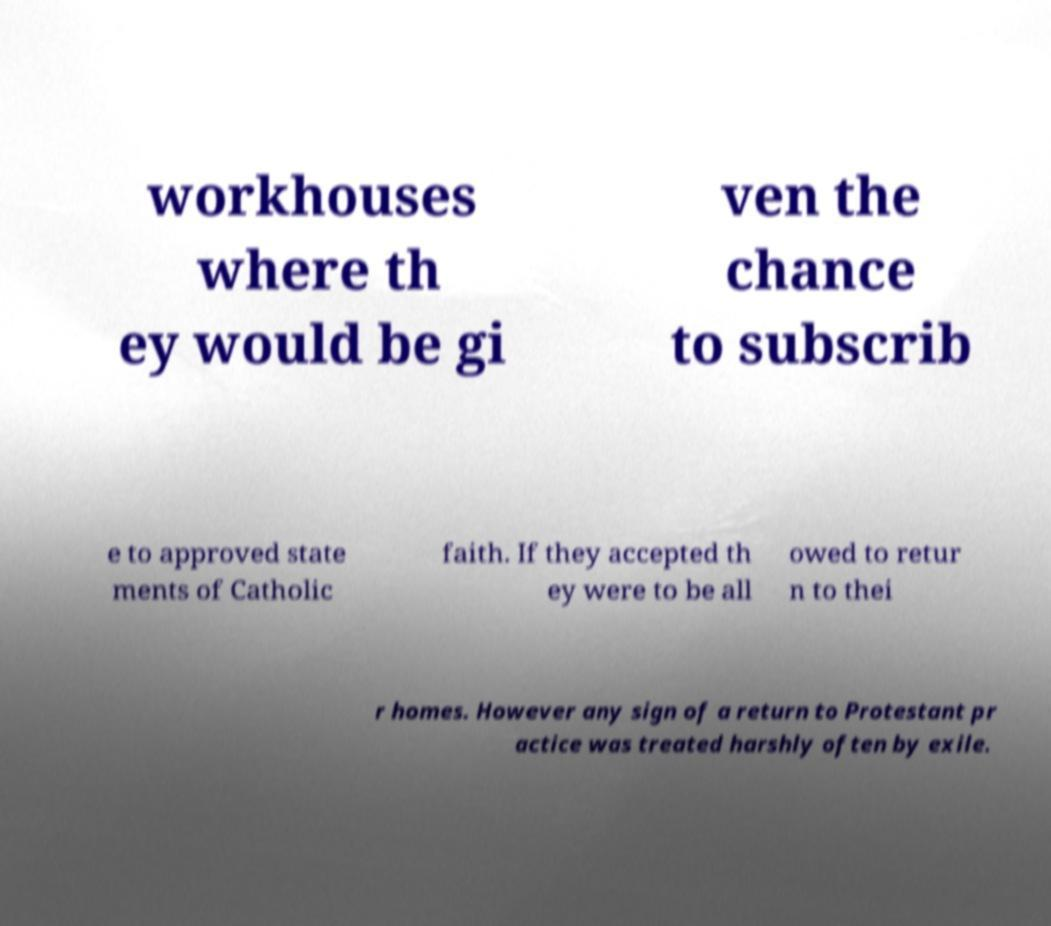Please read and relay the text visible in this image. What does it say? workhouses where th ey would be gi ven the chance to subscrib e to approved state ments of Catholic faith. If they accepted th ey were to be all owed to retur n to thei r homes. However any sign of a return to Protestant pr actice was treated harshly often by exile. 